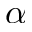<formula> <loc_0><loc_0><loc_500><loc_500>\alpha</formula> 